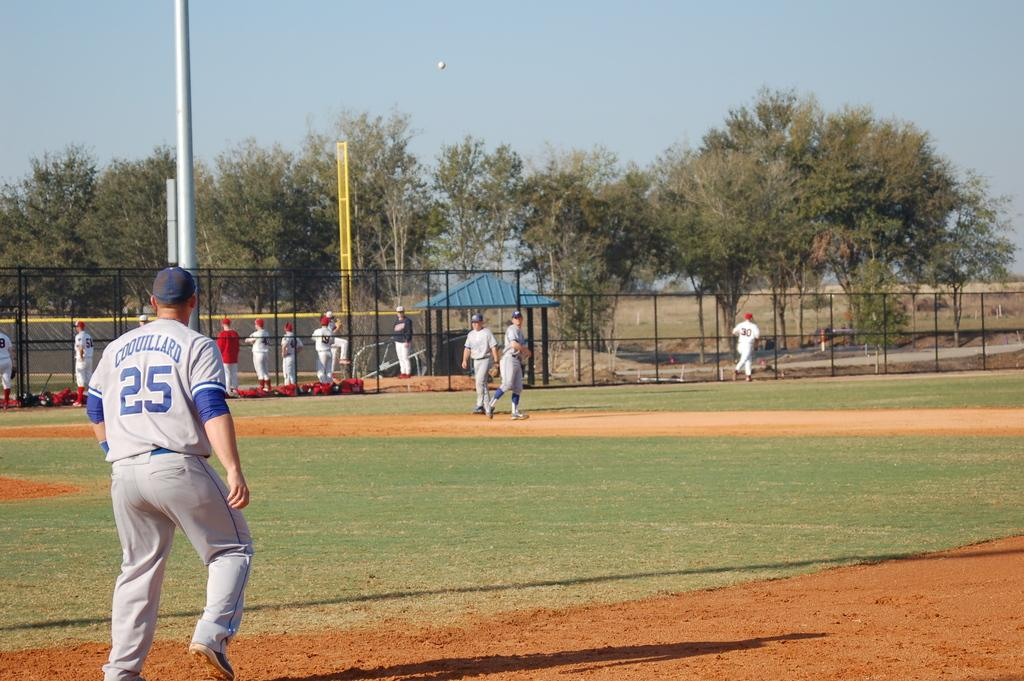Provide a one-sentence caption for the provided image. the number 25 on the back of a jersey. 